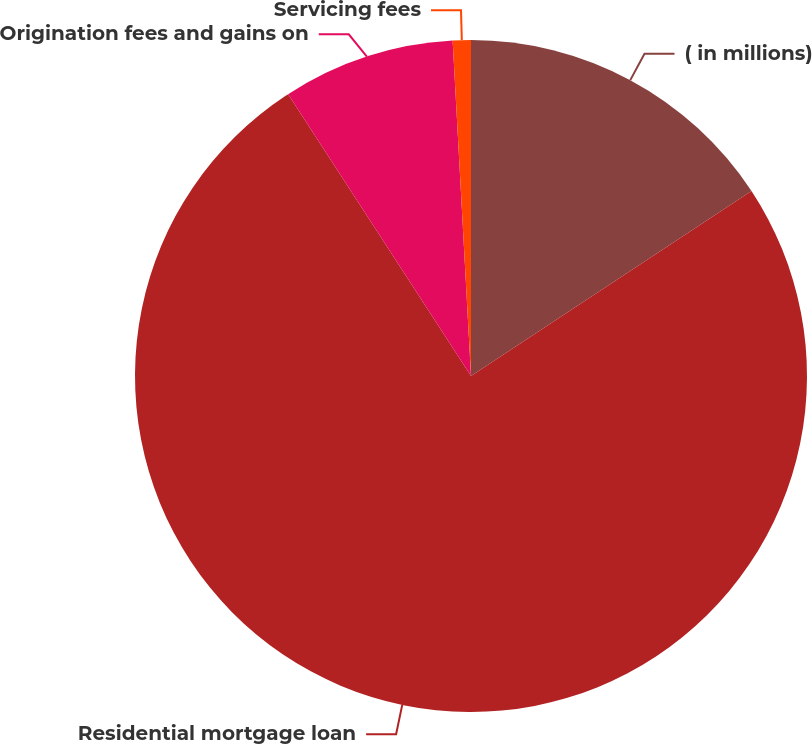Convert chart. <chart><loc_0><loc_0><loc_500><loc_500><pie_chart><fcel>( in millions)<fcel>Residential mortgage loan<fcel>Origination fees and gains on<fcel>Servicing fees<nl><fcel>15.72%<fcel>75.12%<fcel>8.29%<fcel>0.87%<nl></chart> 